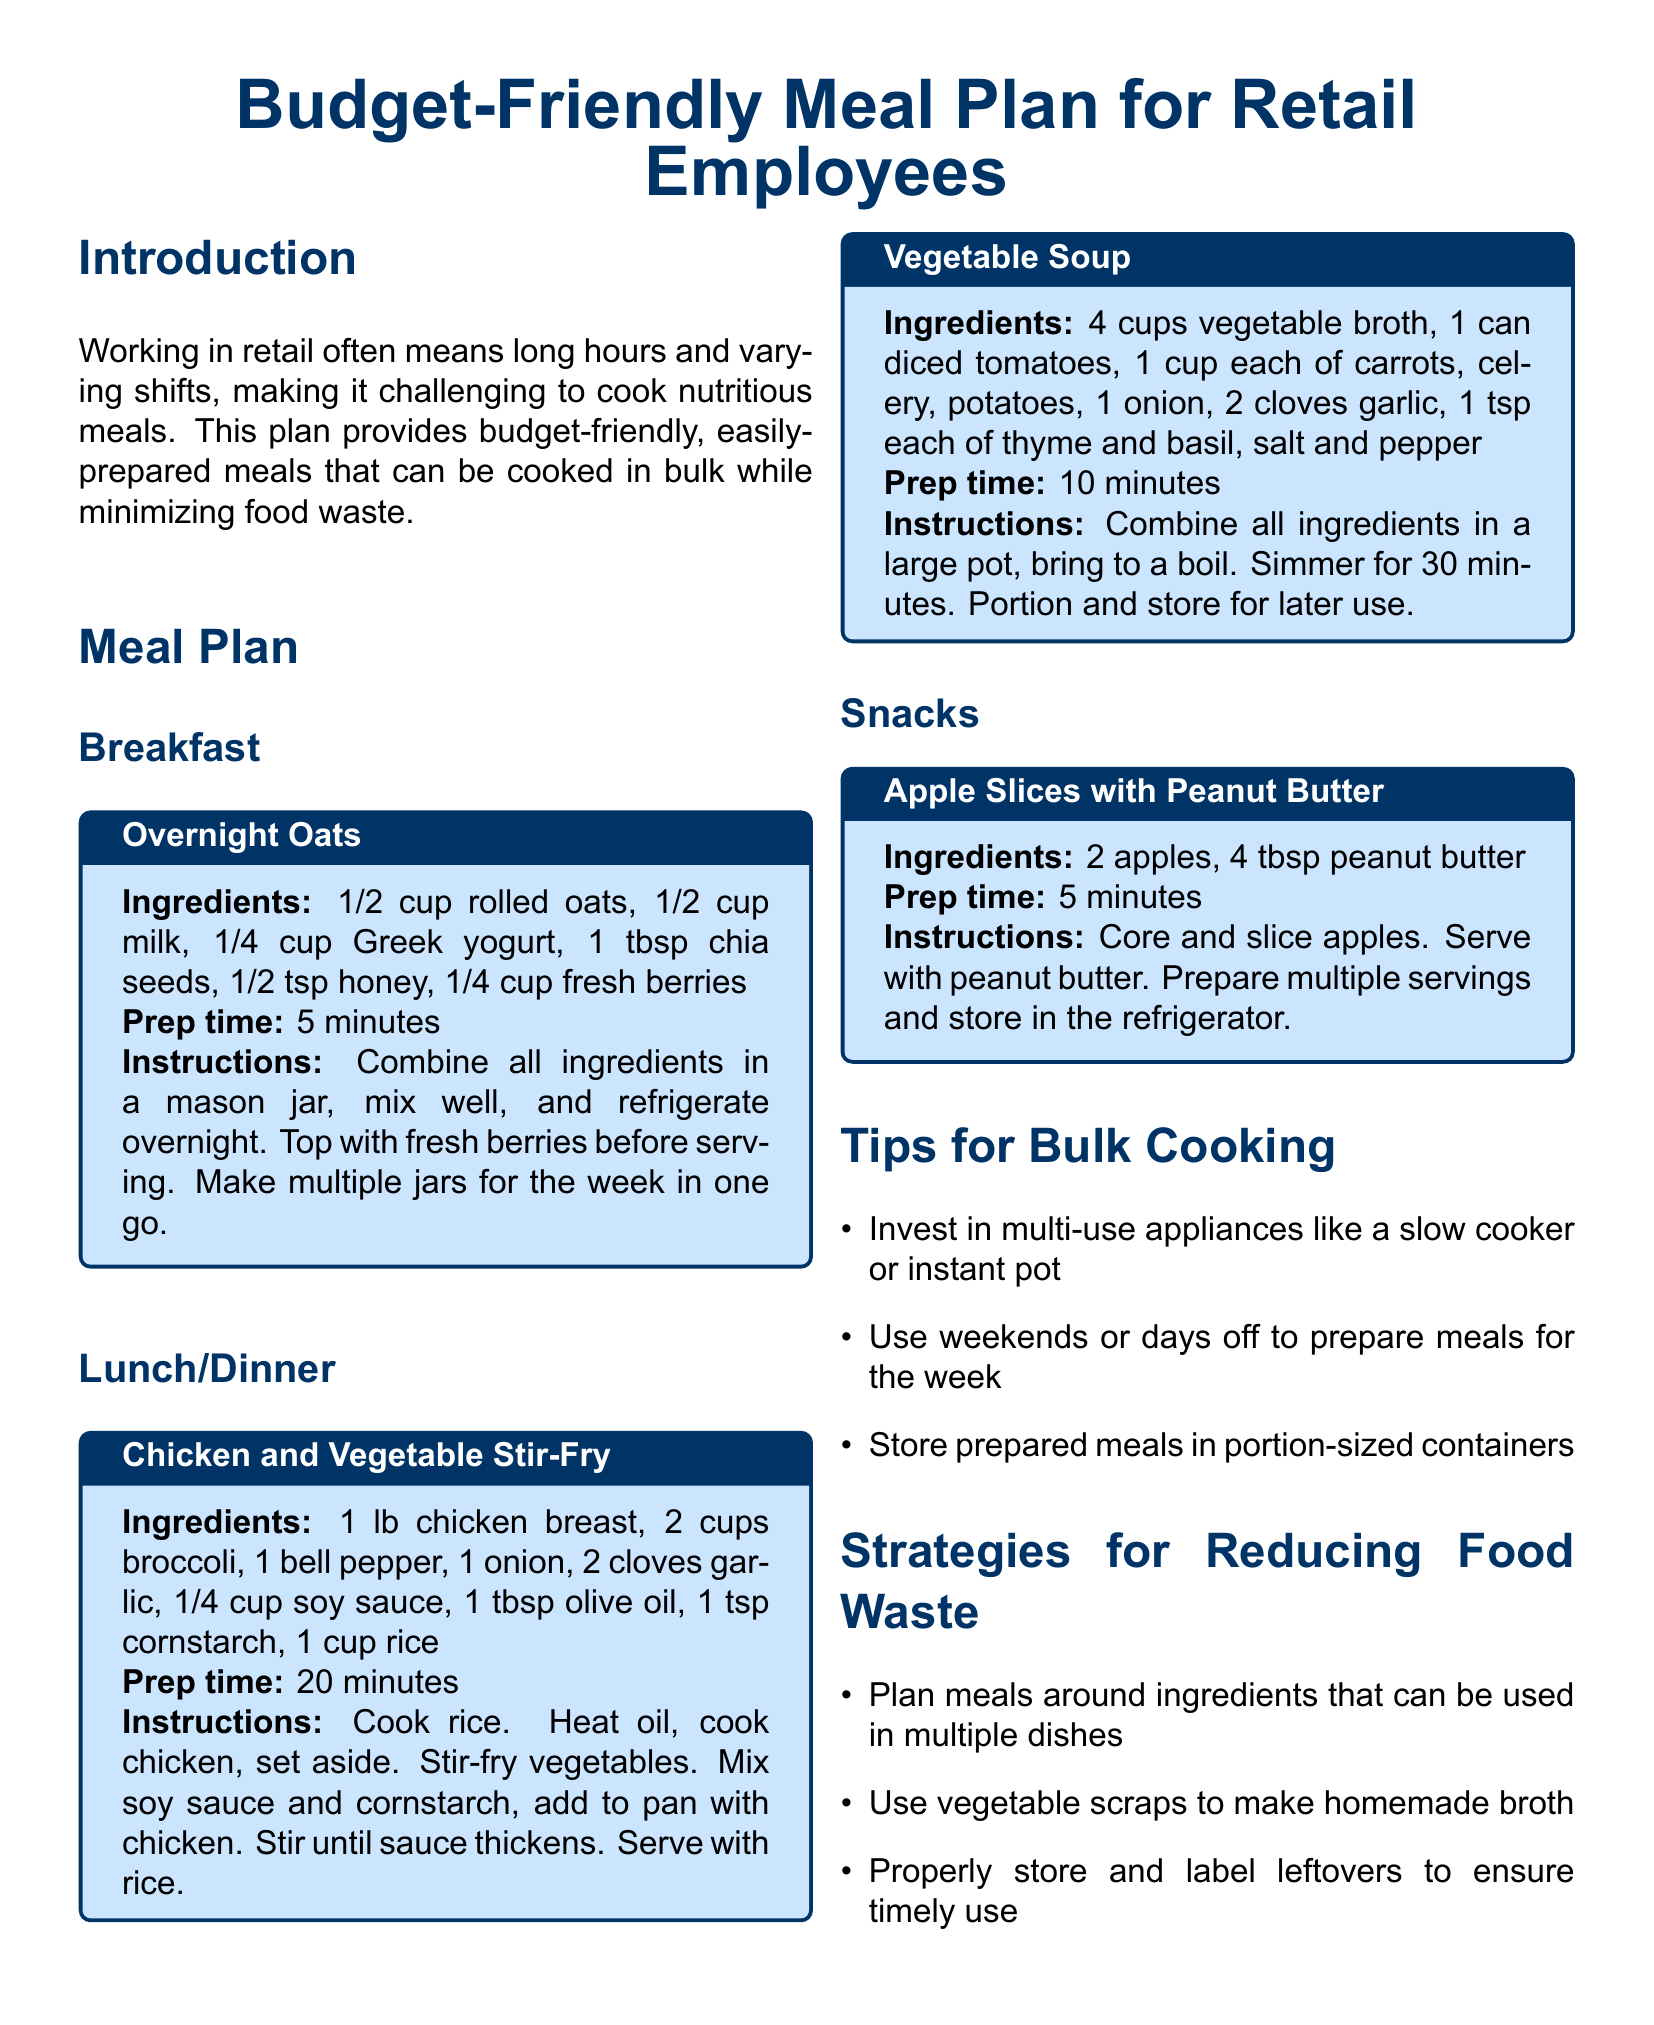What are the ingredients for Overnight Oats? The ingredients for Overnight Oats include rolled oats, milk, Greek yogurt, chia seeds, honey, and fresh berries.
Answer: rolled oats, milk, Greek yogurt, chia seeds, honey, fresh berries How long does it take to prepare Chicken and Vegetable Stir-Fry? The document states that the prep time for Chicken and Vegetable Stir-Fry is 20 minutes.
Answer: 20 minutes What is a suggested strategy for reducing food waste? One of the strategies mentioned is to plan meals around ingredients that can be used in multiple dishes.
Answer: Plan meals around ingredients that can be used in multiple dishes What is the portion size for Apple Slices with Peanut Butter? The preparation suggests serving 2 apples with 4 tablespoons of peanut butter, indicating the portion size for a single serving.
Answer: 2 apples, 4 tbsp peanut butter What type of appliances should be invested in for bulk cooking? The document advises investing in multi-use appliances like a slow cooker or instant pot.
Answer: Slow cooker, instant pot What is the main purpose of the meal plan? The main purpose, as described in the introduction, is to provide budget-friendly, easily-prepared meals that can be cooked in bulk while minimizing food waste.
Answer: Budget-friendly, easily-prepared meals 